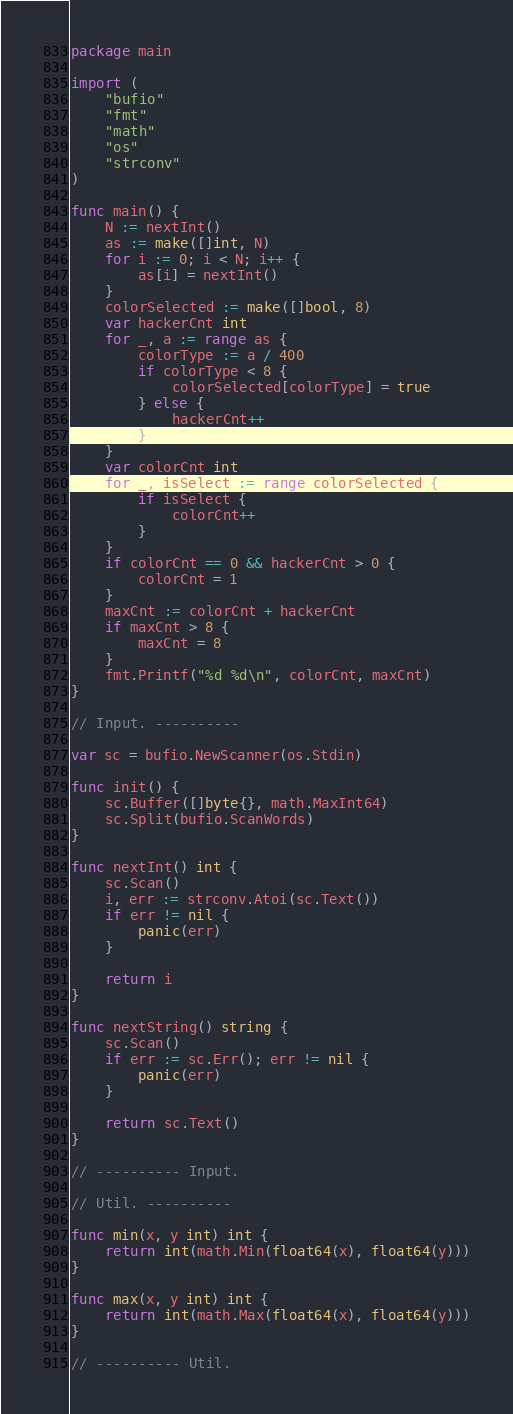Convert code to text. <code><loc_0><loc_0><loc_500><loc_500><_Go_>package main

import (
	"bufio"
	"fmt"
	"math"
	"os"
	"strconv"
)

func main() {
	N := nextInt()
	as := make([]int, N)
	for i := 0; i < N; i++ {
		as[i] = nextInt()
	}
	colorSelected := make([]bool, 8)
	var hackerCnt int
	for _, a := range as {
		colorType := a / 400
		if colorType < 8 {
			colorSelected[colorType] = true
		} else {
			hackerCnt++
		}
	}
	var colorCnt int
	for _, isSelect := range colorSelected {
		if isSelect {
			colorCnt++
		}
	}
	if colorCnt == 0 && hackerCnt > 0 {
		colorCnt = 1
	}
	maxCnt := colorCnt + hackerCnt
	if maxCnt > 8 {
		maxCnt = 8
	}
	fmt.Printf("%d %d\n", colorCnt, maxCnt)
}

// Input. ----------

var sc = bufio.NewScanner(os.Stdin)

func init() {
	sc.Buffer([]byte{}, math.MaxInt64)
	sc.Split(bufio.ScanWords)
}

func nextInt() int {
	sc.Scan()
	i, err := strconv.Atoi(sc.Text())
	if err != nil {
		panic(err)
	}

	return i
}

func nextString() string {
	sc.Scan()
	if err := sc.Err(); err != nil {
		panic(err)
	}

	return sc.Text()
}

// ---------- Input.

// Util. ----------

func min(x, y int) int {
	return int(math.Min(float64(x), float64(y)))
}

func max(x, y int) int {
	return int(math.Max(float64(x), float64(y)))
}

// ---------- Util.
</code> 